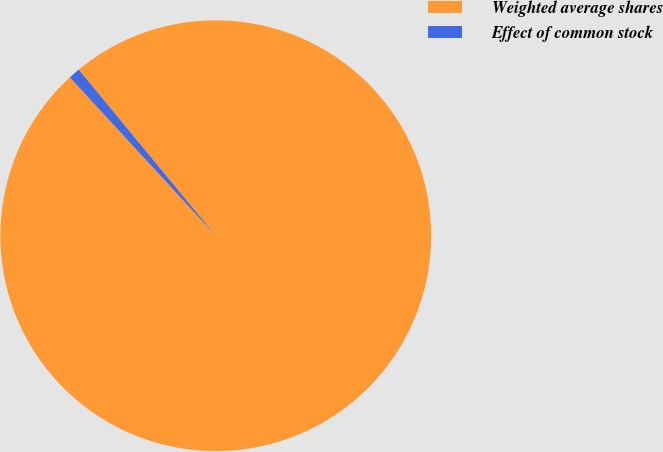<chart> <loc_0><loc_0><loc_500><loc_500><pie_chart><fcel>Weighted average shares<fcel>Effect of common stock<nl><fcel>99.13%<fcel>0.87%<nl></chart> 